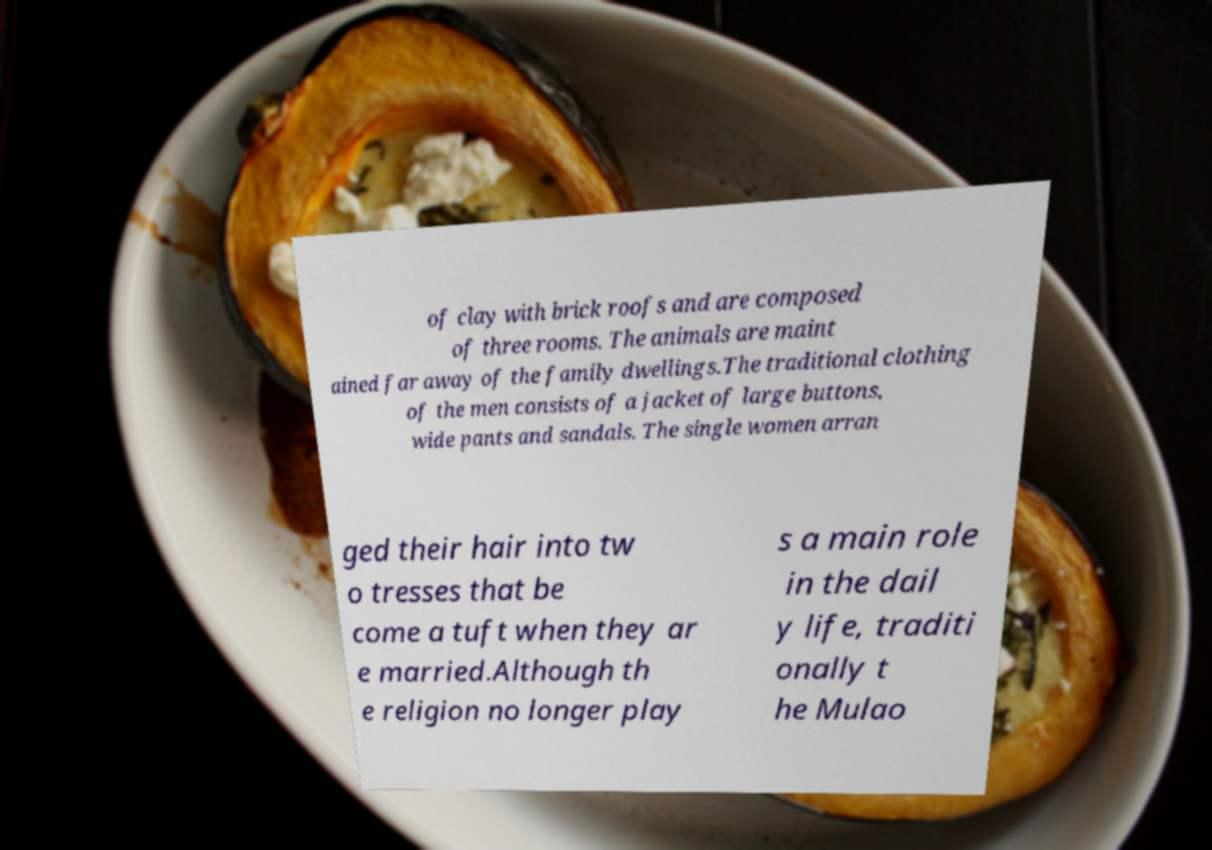Please read and relay the text visible in this image. What does it say? of clay with brick roofs and are composed of three rooms. The animals are maint ained far away of the family dwellings.The traditional clothing of the men consists of a jacket of large buttons, wide pants and sandals. The single women arran ged their hair into tw o tresses that be come a tuft when they ar e married.Although th e religion no longer play s a main role in the dail y life, traditi onally t he Mulao 